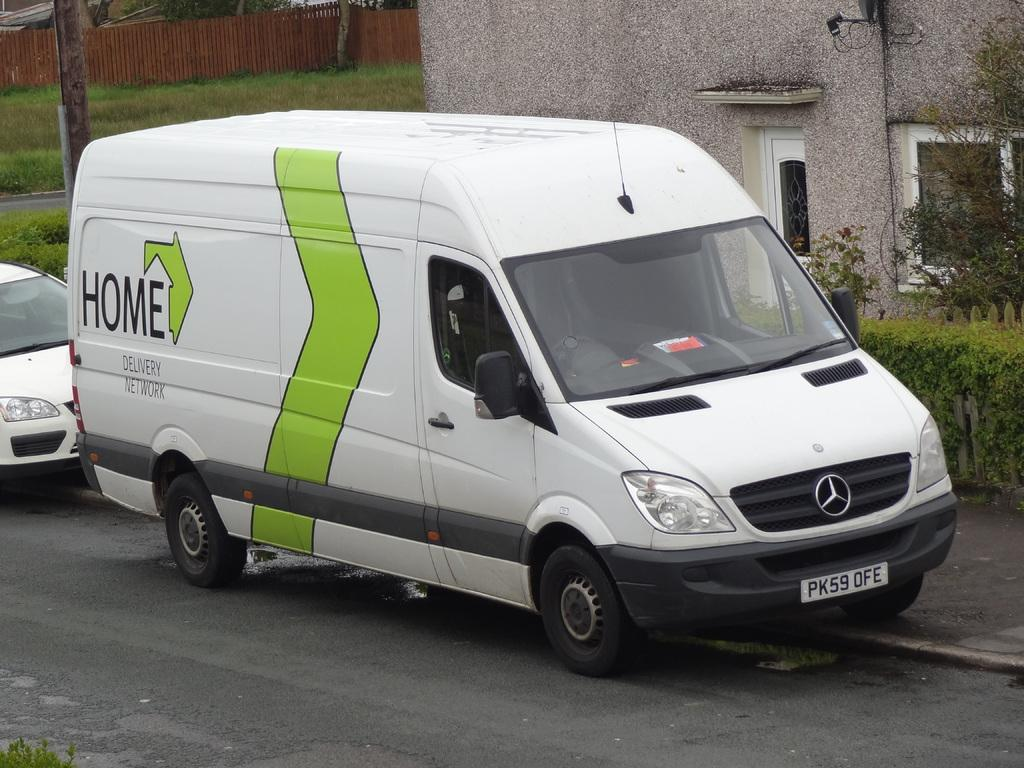Provide a one-sentence caption for the provided image. A white Mercedes van that says Home Delivery Network on it. 